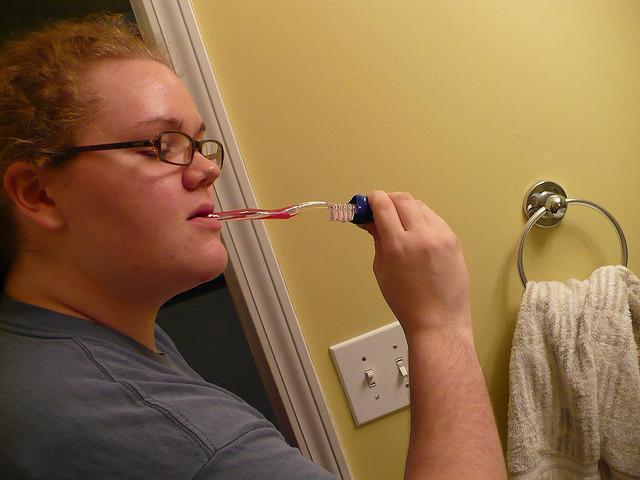How many kites are in the air?
Give a very brief answer. 0. 